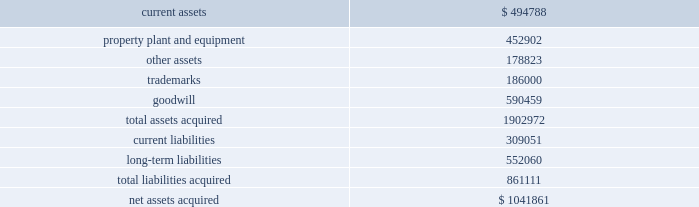Mondavi produces , markets and sells premium , super-premium and fine california wines under the woodbridge by robert mondavi , robert mondavi private selection and robert mondavi winery brand names .
Woodbridge and robert mondavi private selection are the leading premium and super-premium wine brands by volume , respectively , in the united states .
The acquisition of robert mondavi supports the company 2019s strategy of strengthening the breadth of its portfolio across price segments to capitalize on the overall growth in the pre- mium , super-premium and fine wine categories .
The company believes that the acquired robert mondavi brand names have strong brand recognition globally .
The vast majority of robert mondavi 2019s sales are generated in the united states .
The company intends to leverage the robert mondavi brands in the united states through its selling , marketing and distribution infrastructure .
The company also intends to further expand distribution for the robert mondavi brands in europe through its constellation europe infrastructure .
The company and robert mondavi have complementary busi- nesses that share a common growth orientation and operating philosophy .
The robert mondavi acquisition provides the company with a greater presence in the fine wine sector within the united states and the ability to capitalize on the broader geographic distribution in strategic international markets .
The robert mondavi acquisition supports the company 2019s strategy of growth and breadth across categories and geographies , and strengthens its competitive position in its core markets .
In par- ticular , the company believes there are growth opportunities for premium , super-premium and fine wines in the united kingdom , united states and other wine markets .
Total consid- eration paid in cash to the robert mondavi shareholders was $ 1030.7 million .
Additionally , the company expects to incur direct acquisition costs of $ 11.2 million .
The purchase price was financed with borrowings under the company 2019s 2004 credit agreement ( as defined in note 9 ) .
In accordance with the pur- chase method of accounting , the acquired net assets are recorded at fair value at the date of acquisition .
The purchase price was based primarily on the estimated future operating results of robert mondavi , including the factors described above , as well as an estimated benefit from operating cost synergies .
The results of operations of the robert mondavi business are reported in the constellation wines segment and have been included in the consolidated statement of income since the acquisition date .
The table summarizes the estimated fair values of the assets acquired and liabilities assumed in the robert mondavi acquisition at the date of acquisition .
The company is in the process of obtaining third-party valuations of certain assets and liabilities , and refining its restructuring plan which is under development and will be finalized during the company 2019s year ending february 28 , 2006 ( see note19 ) .
Accordingly , the allocation of the purchase price is subject to refinement .
Estimated fair values at december 22 , 2004 , are as follows : {in thousands} .
The trademarks are not subject to amortization .
None of the goodwill is expected to be deductible for tax purposes .
In connection with the robert mondavi acquisition and robert mondavi 2019s previously disclosed intention to sell certain of its winery properties and related assets , and other vineyard prop- erties , the company has classified certain assets as held for sale as of february 28 , 2005 .
The company expects to sell these assets during the year ended february 28 , 2006 , for net pro- ceeds of approximately $ 150 million to $ 175 million .
No gain or loss is expected to be recognized upon the sale of these assets .
Hardy acquisition 2013 on march 27 , 2003 , the company acquired control of brl hardy limited , now known as hardy wine company limited ( 201chardy 201d ) , and on april 9 , 2003 , the company completed its acquisition of all of hardy 2019s outstanding capital stock .
As a result of the acquisition of hardy , the company also acquired the remaining 50% ( 50 % ) ownership of pacific wine partners llc ( 201cpwp 201d ) , the joint venture the company established with hardy in july 2001 .
The acquisition of hardy along with the remaining interest in pwp is referred to together as the 201chardy acquisition . 201d through this acquisition , the company acquired one of australia 2019s largest wine producers with interests in winer- ies and vineyards in most of australia 2019s major wine regions as well as new zealand and the united states and hardy 2019s market- ing and sales operations in the united kingdom .
Total consideration paid in cash and class a common stock to the hardy shareholders was $ 1137.4 million .
Additionally , the company recorded direct acquisition costs of $ 17.2 million .
The acquisition date for accounting purposes is march 27 , 2003 .
The company has recorded a $ 1.6 million reduction in the purchase price to reflect imputed interest between the accounting acquisition date and the final payment of consider- ation .
This charge is included as interest expense in the consolidated statement of income for the year ended february 29 , 2004 .
The cash portion of the purchase price paid to the hardy shareholders and optionholders ( $ 1060.2 mil- lion ) was financed with $ 660.2 million of borrowings under the company 2019s then existing credit agreement and $ 400.0 million .
What portion of the net asset acquired is related to goodwill? 
Computations: (590459 / 1041861)
Answer: 0.56673. 